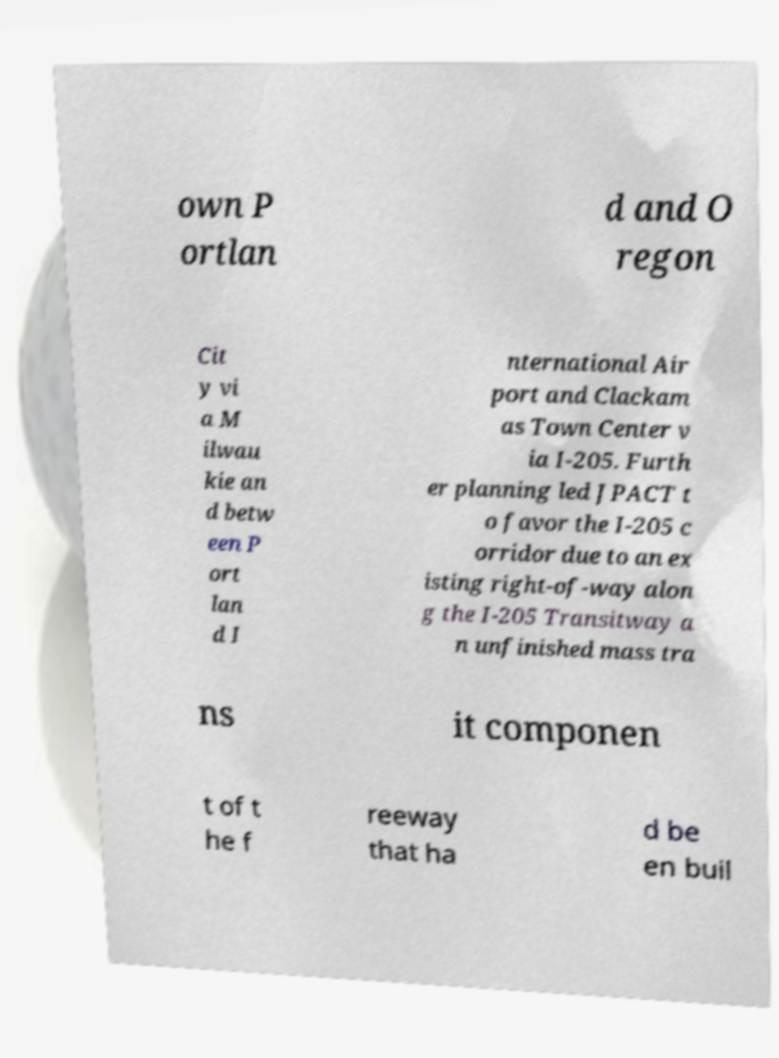What messages or text are displayed in this image? I need them in a readable, typed format. own P ortlan d and O regon Cit y vi a M ilwau kie an d betw een P ort lan d I nternational Air port and Clackam as Town Center v ia I-205. Furth er planning led JPACT t o favor the I-205 c orridor due to an ex isting right-of-way alon g the I-205 Transitway a n unfinished mass tra ns it componen t of t he f reeway that ha d be en buil 